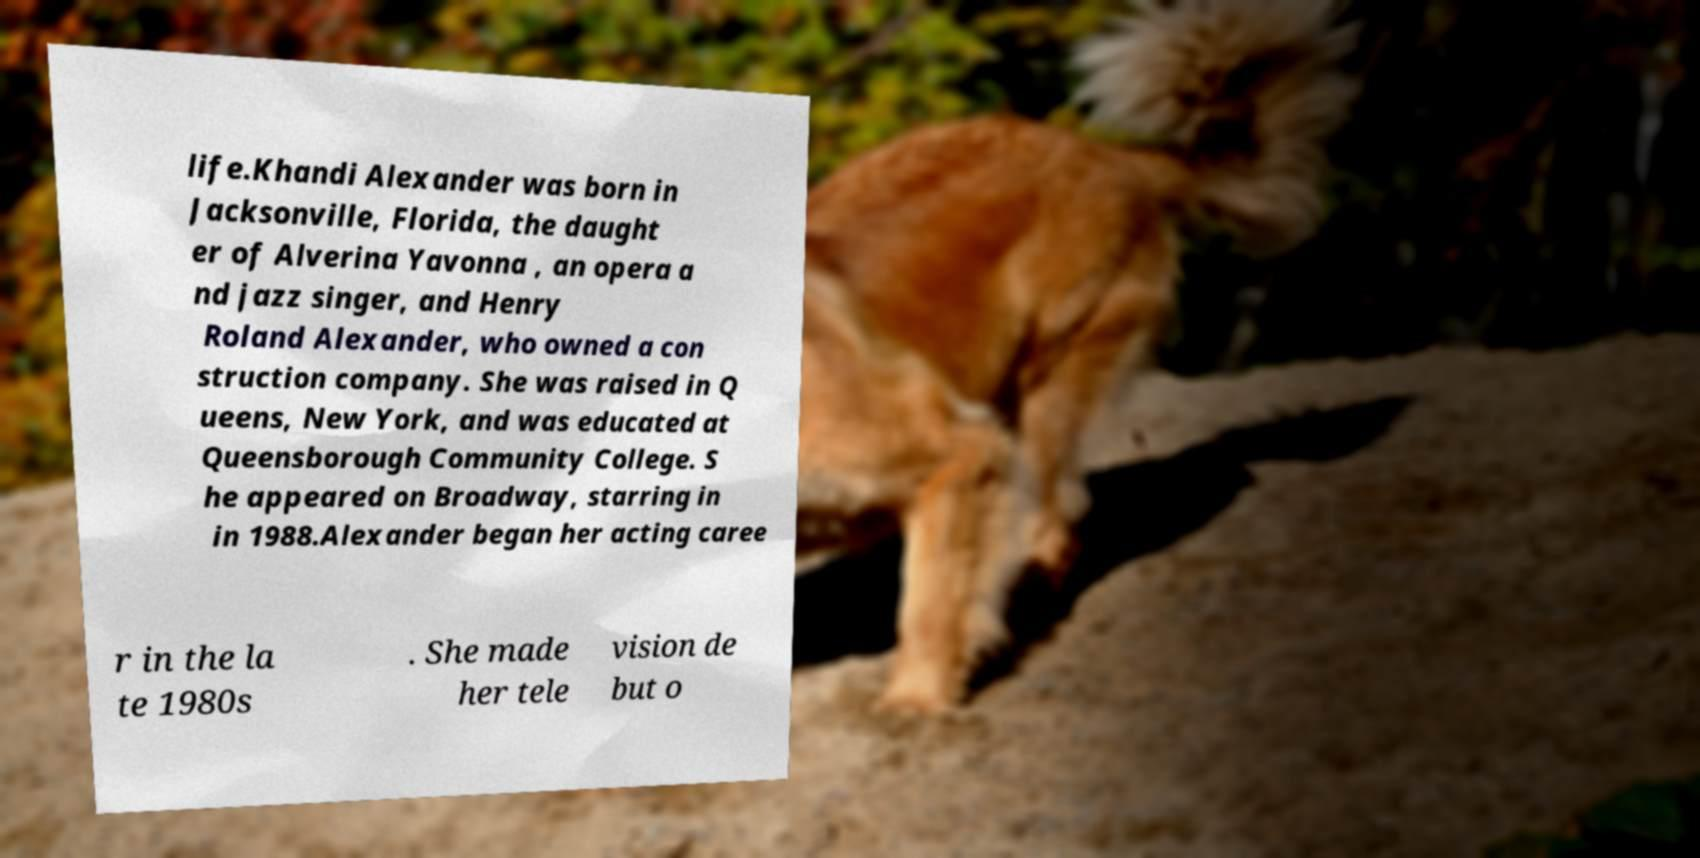I need the written content from this picture converted into text. Can you do that? life.Khandi Alexander was born in Jacksonville, Florida, the daught er of Alverina Yavonna , an opera a nd jazz singer, and Henry Roland Alexander, who owned a con struction company. She was raised in Q ueens, New York, and was educated at Queensborough Community College. S he appeared on Broadway, starring in in 1988.Alexander began her acting caree r in the la te 1980s . She made her tele vision de but o 